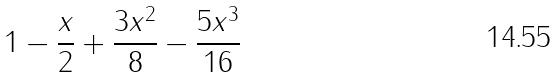<formula> <loc_0><loc_0><loc_500><loc_500>1 - \frac { x } { 2 } + \frac { 3 x ^ { 2 } } { 8 } - \frac { 5 x ^ { 3 } } { 1 6 }</formula> 